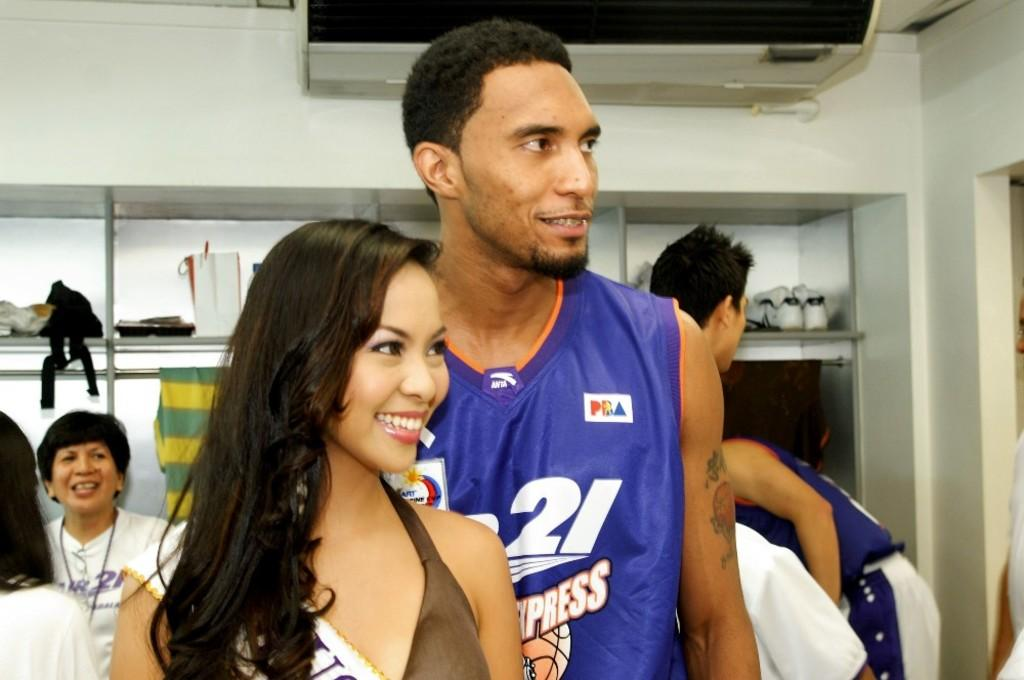<image>
Describe the image concisely. A woman is posting with a male basketball player with the number 21 on his jersey. 